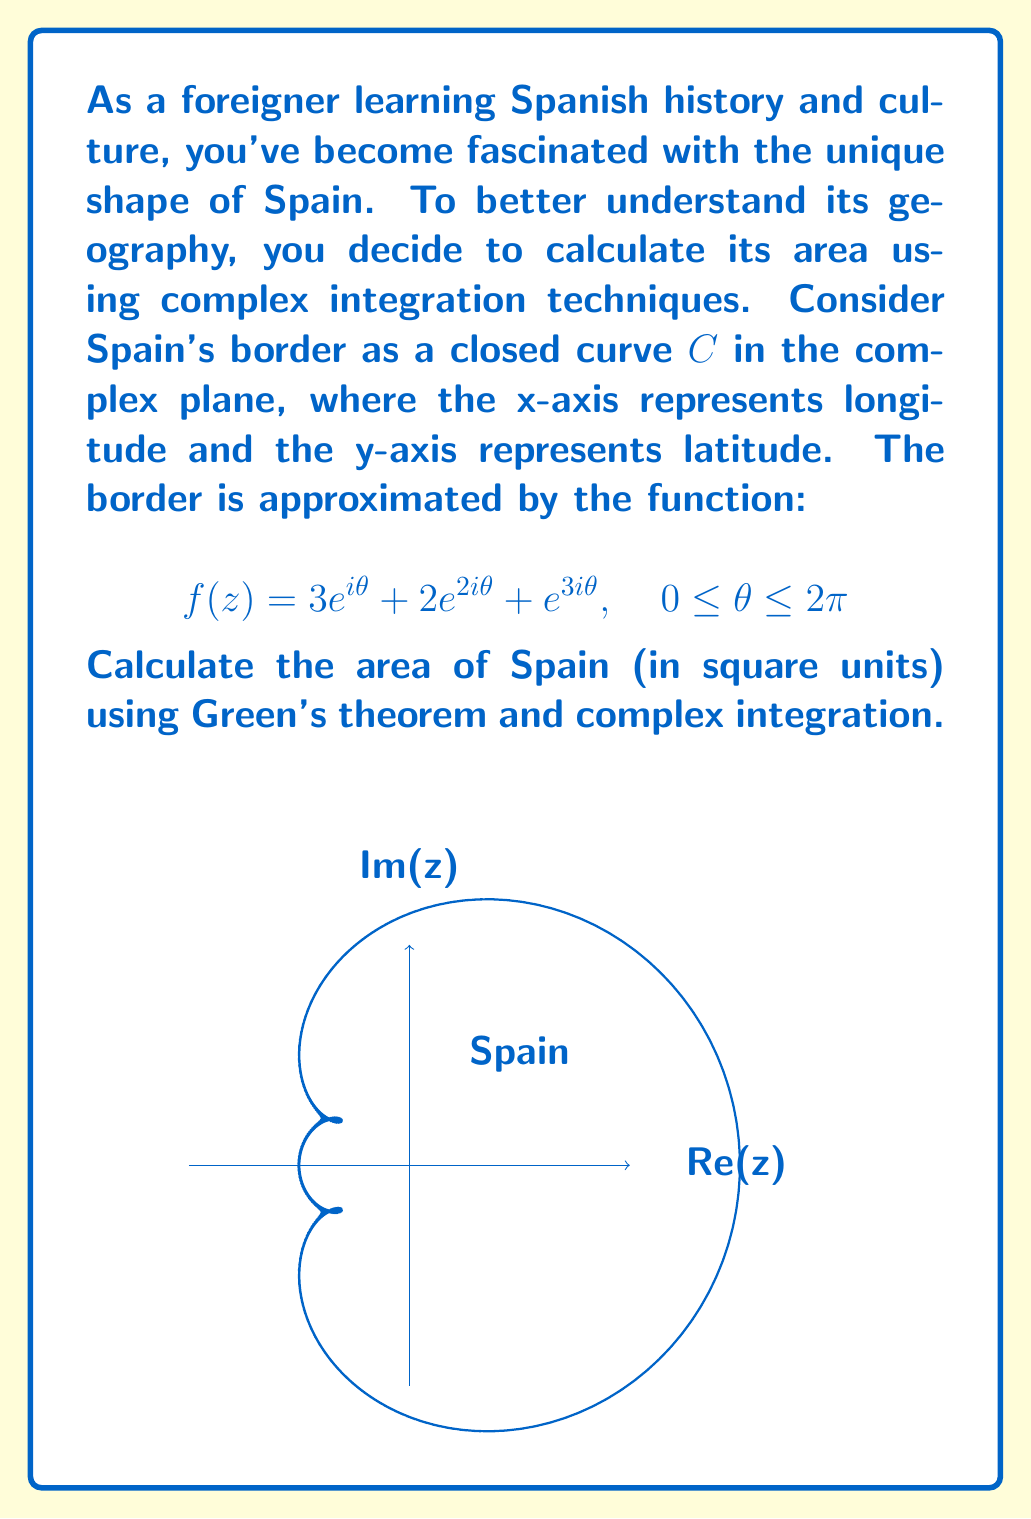Could you help me with this problem? Let's approach this step-by-step using Green's theorem and complex integration:

1) Green's theorem states that for a positively oriented, piecewise smooth, simple closed curve $C$ in a plane:

   $$\oint_C (P dx + Q dy) = \iint_D \left(\frac{\partial Q}{\partial x} - \frac{\partial P}{\partial y}\right) dA$$

   where $D$ is the region bounded by $C$.

2) For the area calculation, we can choose $P = -y/2$ and $Q = x/2$. This gives:

   $$\text{Area} = \frac{1}{2} \oint_C (x dy - y dx) = \frac{1}{2i} \oint_C z d\bar{z}$$

3) In our case, $z = f(z) = 3e^{i\theta} + 2e^{2i\theta} + e^{3i\theta}$

4) We need to calculate $d\bar{z}$:
   
   $$d\bar{z} = (-3ie^{-i\theta} - 4ie^{-2i\theta} - 3ie^{-3i\theta}) d\theta$$

5) Now, let's compute the integral:

   $$\begin{align*}
   \text{Area} &= \frac{1}{2i} \int_0^{2\pi} (3e^{i\theta} + 2e^{2i\theta} + e^{3i\theta})(-3ie^{-i\theta} - 4ie^{-2i\theta} - 3ie^{-3i\theta}) d\theta \\
   &= \frac{1}{2} \int_0^{2\pi} (9 + 6e^{i\theta} + 3e^{2i\theta} + 12e^{-i\theta} + 8 + 6e^{-i\theta} + 9e^{-2i\theta} + 6e^{-i\theta} + 3) d\theta
   \end{align*}$$

6) Most terms will integrate to zero over $[0, 2\pi]$ except the constant terms:

   $$\text{Area} = \frac{1}{2} \int_0^{2\pi} (9 + 8 + 3) d\theta = 10\pi$$

Therefore, the area of Spain in this model is $10\pi$ square units.
Answer: $10\pi$ square units 